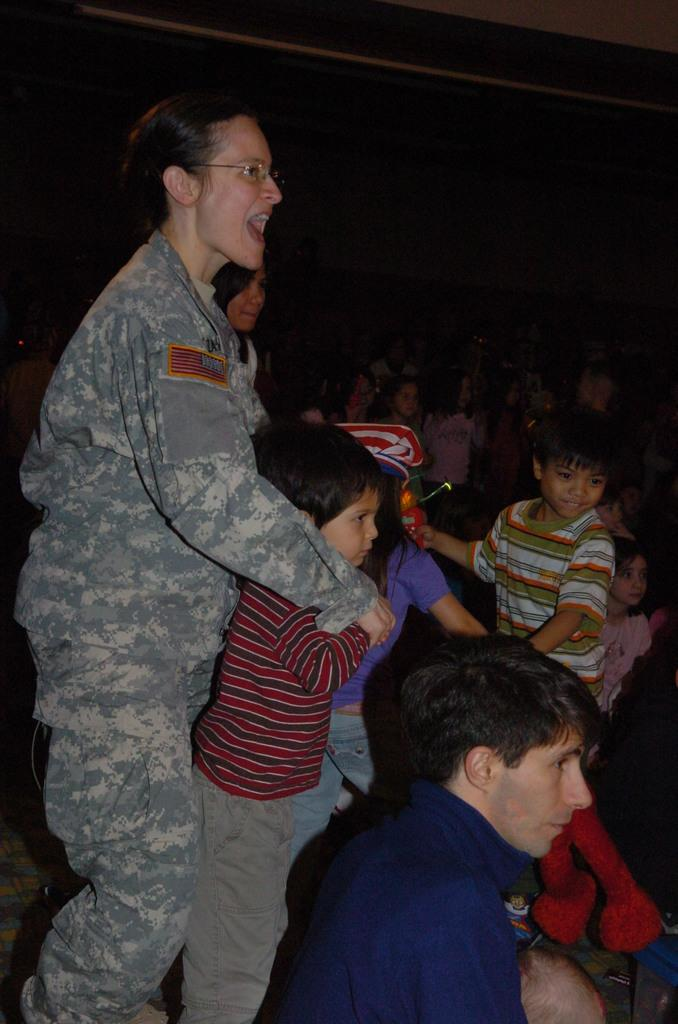What type of person is depicted in the image? There is a soldier in the image. Who else is present in the image besides the soldier? There are kids around the soldier. Can you describe the overall scene in the image? There are people in the image, including the soldier and the kids. What type of bat can be seen flying in the image? There is no bat present in the image; it features a soldier and kids. What type of land can be seen in the image? The image does not depict any specific land or terrain; it focuses on the soldier and the kids. 